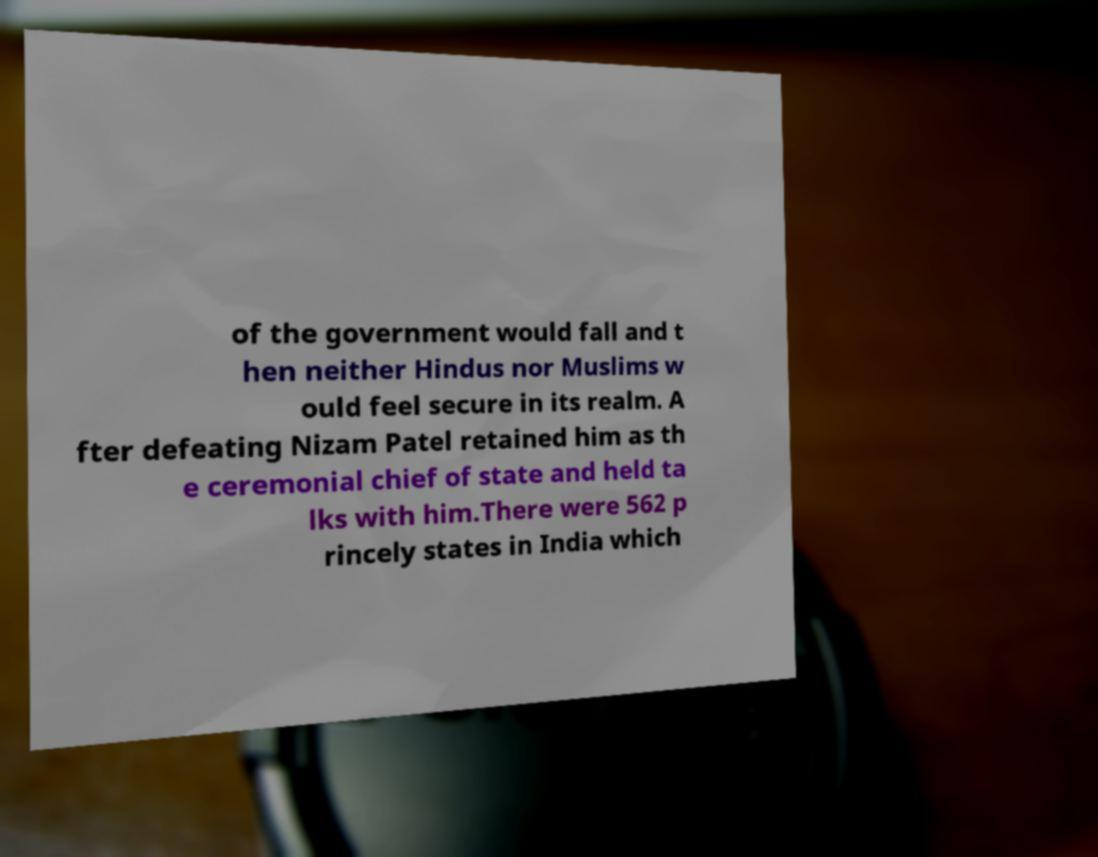Please read and relay the text visible in this image. What does it say? of the government would fall and t hen neither Hindus nor Muslims w ould feel secure in its realm. A fter defeating Nizam Patel retained him as th e ceremonial chief of state and held ta lks with him.There were 562 p rincely states in India which 